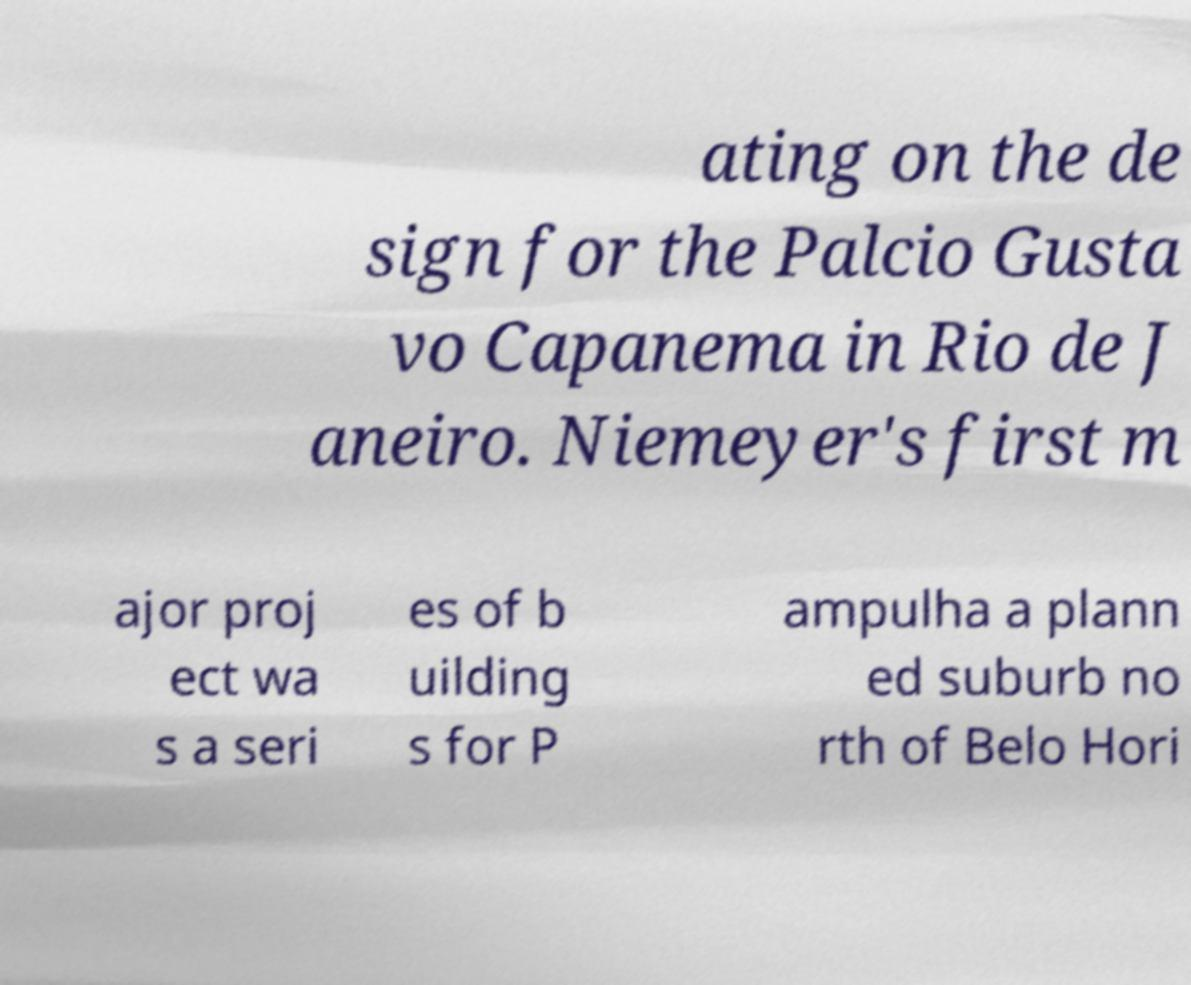Please identify and transcribe the text found in this image. ating on the de sign for the Palcio Gusta vo Capanema in Rio de J aneiro. Niemeyer's first m ajor proj ect wa s a seri es of b uilding s for P ampulha a plann ed suburb no rth of Belo Hori 